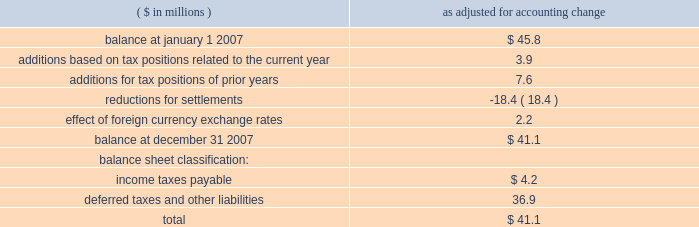Page 62 of 94 notes to consolidated financial statements ball corporation and subsidiaries 14 .
Taxes on income ( continued ) at december 31 , 2007 , ball corporation and its domestic subsidiaries had net operating loss carryforwards , expiring between 2020 and 2026 , of $ 64.6 million with a related tax benefit of $ 25.2 million .
Also at december 31 , 2007 , ball packaging europe and its subsidiaries had net operating loss carryforwards , with no expiration date , of $ 54.4 million with a related tax benefit of $ 14.6 million .
Ball packaging products canada corp .
Had a net operating loss carryforward , with no expiration date , of $ 15.8 million with a related tax benefit of $ 5.4 million .
Due to the uncertainty of ultimate realization , these european and canadian benefits have been offset by valuation allowances of $ 8.6 million and $ 5.4 million , respectively .
Upon realization , $ 5.3 million of the european valuation allowance will be recognized as a reduction in goodwill .
At december 31 , 2007 , the company has foreign tax credit carryforwards of $ 5.8 million ; however , due to the uncertainty of realization of the entire credit , a valuation allowance of $ 3.8 million has been applied to reduce the carrying value to $ 2 million .
Effective january 1 , 2007 , ball adopted fin no .
48 , 201caccounting for uncertainty in income taxes . 201d as of the date of adoption , the accrual for uncertain tax position was $ 45.8 million , and the cumulative effect of the adoption was an increase in the reserve for uncertain tax positions of $ 2.1 million .
The accrual includes an $ 11.4 million reduction in opening retained earnings and a $ 9.3 million reduction in goodwill .
A reconciliation of the unrecognized tax benefits follows : ( $ in millions ) as adjusted for accounting change .
The amount of unrecognized tax benefits at december 31 , 2007 , that , if recognized , would reduce tax expense is $ 35.9 million .
At this time there are no positions where the unrecognized tax benefit is expected to increase or decrease significantly within the next 12 months .
U.s .
Federal and state income tax returns filed for the years 2000- 2006 are open for audit , with an effective settlement of the federal returns through 2004 .
The income tax returns filed in europe for the years 2002 through 2006 are also open for audit .
The company 2019s significant filings in europe are in germany , france , the netherlands , poland , serbia and the united kingdom .
The company recognizes the accrual of interest and penalties related to unrecognized tax benefits in income tax expense .
During the year ended december 31 , 2007 , ball recognized approximately $ 2.7 million of interest expense .
The accrual for uncertain tax positions at december 31 , 2007 , includes approximately $ 5.1 million representing potential interest expense .
No penalties have been accrued .
The 2007 provision for income taxes included an $ 11.5 million accrual under fin no .
48 .
The majority of this provision was related to the effective settlement during the third quarter of 2007 with the internal revenue service for interest deductions on incurred loans from a company-owned life insurance plan .
The total accrual at december 31 , 2007 , for the effective settlement of the applicable prior years 2000-2004 under examination , and unaudited years 2005 through 2007 , was $ 18.4 million , including estimated interest .
The settlement resulted in a majority of the interest deductions being sustained with prospective application that results in no significant impact to future earnings per share or cash flows. .
What percentage of total unrecognized tax benefits as of december 31 , 2007 is comprised of deferred taxes and other liabilities? 
Computations: (36.9 / 41.1)
Answer: 0.89781. 